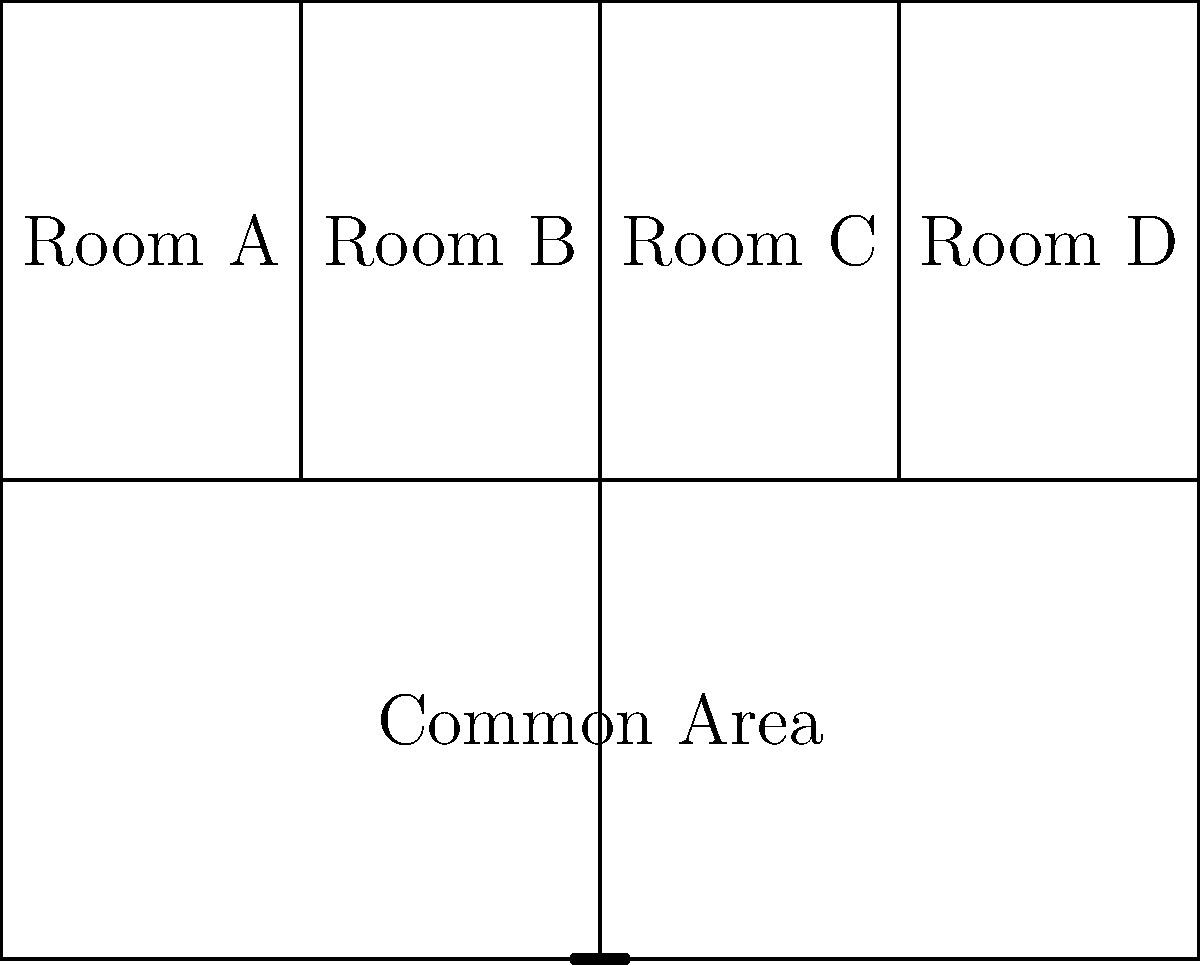Based on the layout of the Beta Theta Pi fraternity house at the University of Miami shown above, what is the total number of individual rooms on the upper floor? To determine the number of individual rooms on the upper floor of the Beta Theta Pi fraternity house, let's analyze the diagram step-by-step:

1. The house is divided into two main sections: an upper floor and a lower floor.
2. The dividing line between the upper and lower floors is clearly visible, running horizontally across the middle of the diagram.
3. On the upper floor, we can see vertical lines dividing the space into separate areas.
4. Counting from left to right, we can identify four distinct spaces on the upper floor:
   - Room A
   - Room B
   - Room C
   - Room D
5. Each of these spaces is labeled as a separate room.

Therefore, by counting the number of distinct, labeled spaces on the upper floor, we can conclude that there are 4 individual rooms.
Answer: 4 rooms 